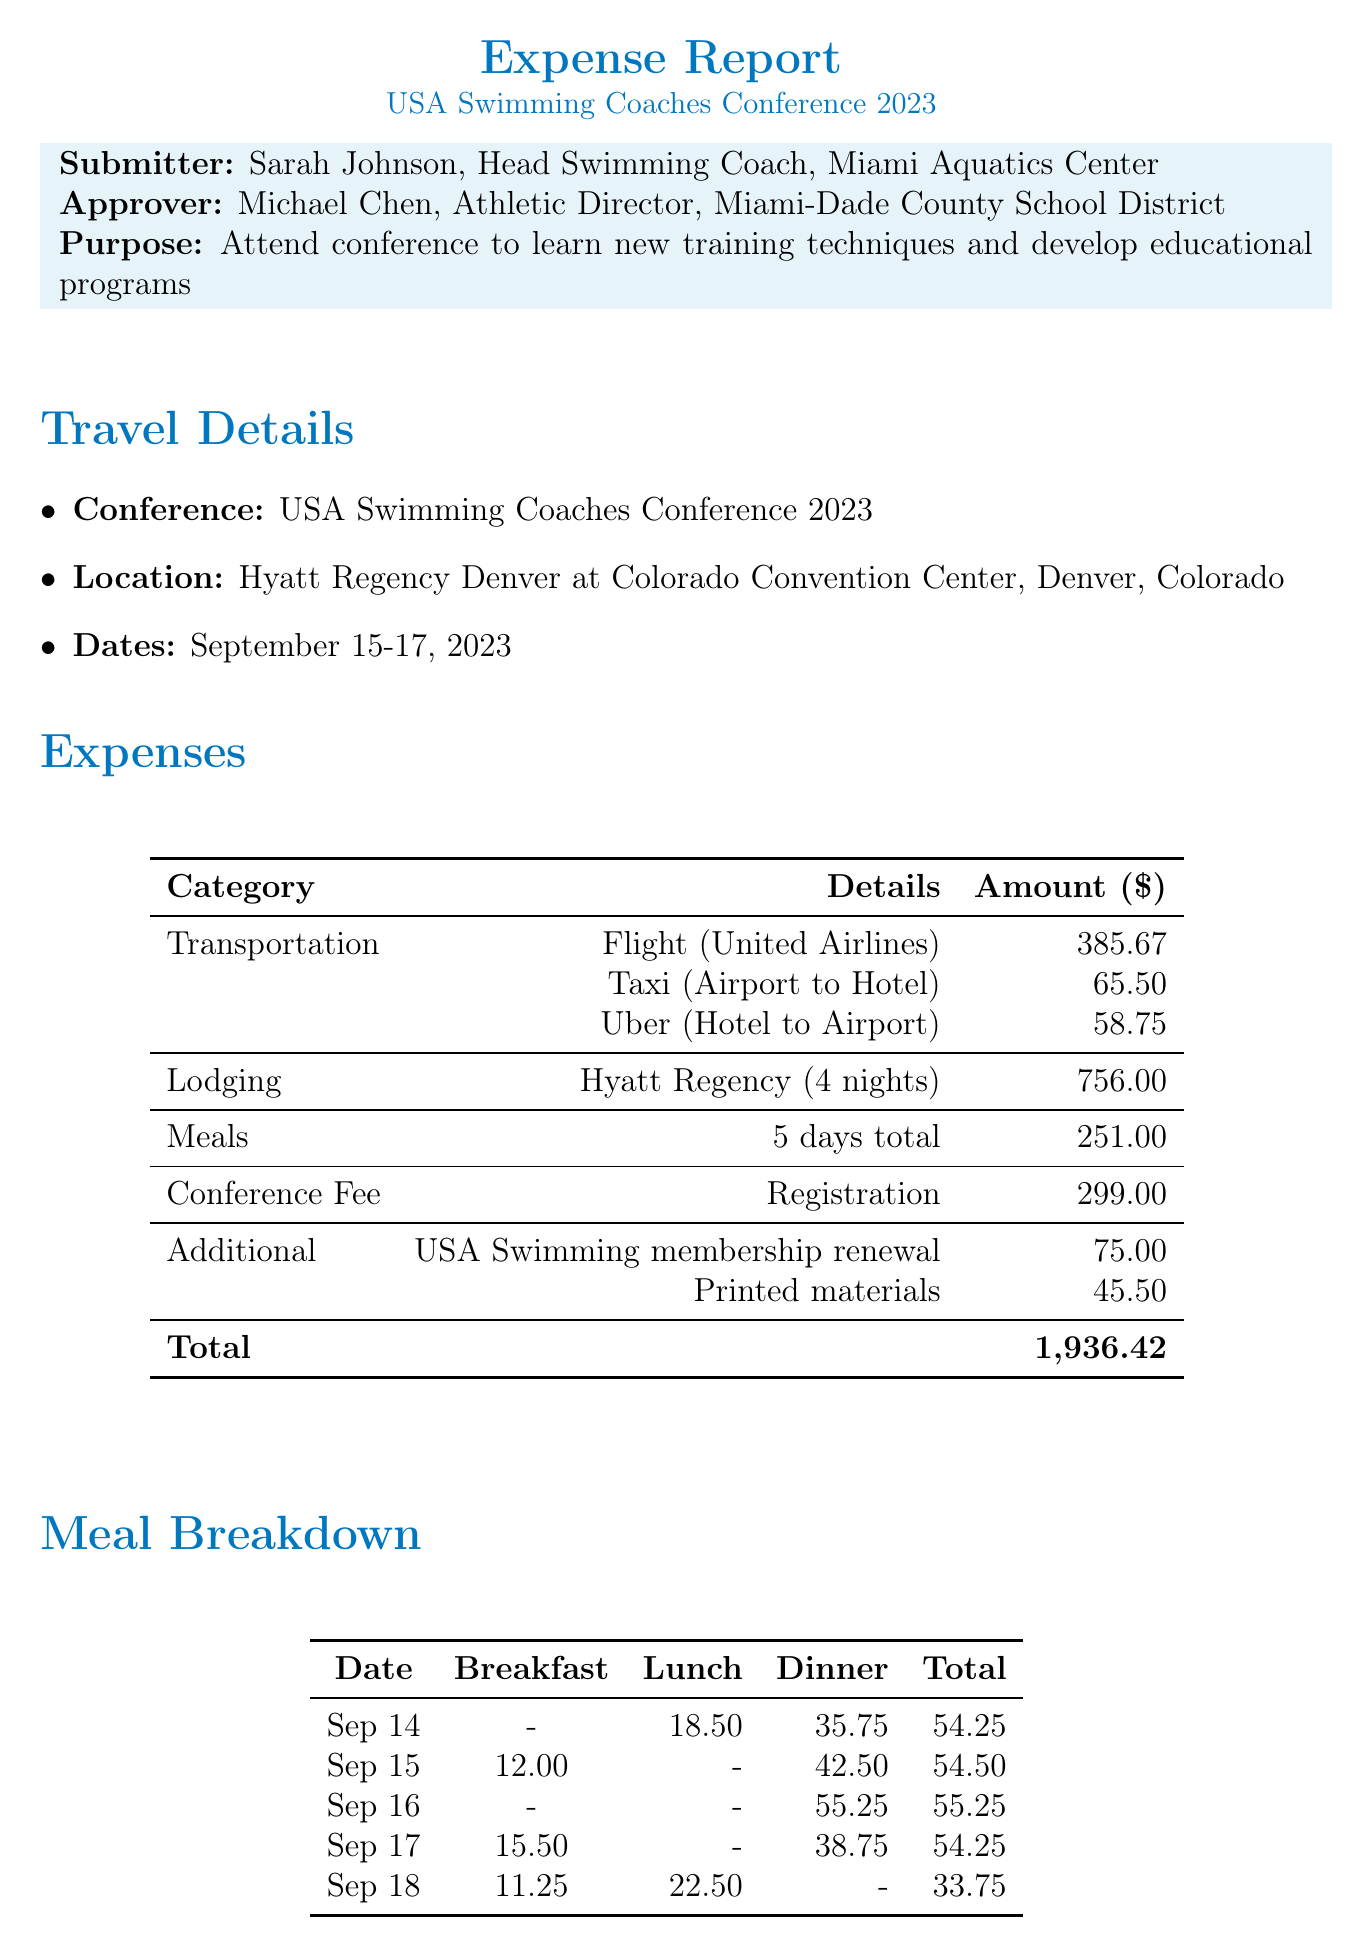What is the total cost of transportation? The total cost of transportation is the sum of flight, taxi, and Uber expenses, which is 385.67 + 65.50 + 58.75 = 509.92.
Answer: 509.92 What hotel was used for lodging? The document specifies the lodging hotel as Hyatt Regency Denver at Colorado Convention Center.
Answer: Hyatt Regency Denver at Colorado Convention Center What are the dates of the conference? The conference dates are explicitly mentioned in the document as September 15-17, 2023.
Answer: September 15-17, 2023 How much did the conference registration fee cost? The cost of the conference registration fee is listed in the additional expenses section as 299.00.
Answer: 299.00 How many nights did the lodging last? The document states that the lodging lasted for 4 nights.
Answer: 4 nights What is the total amount spent on meals? The total amount spent on meals is provided in the expenses summary as 251.00.
Answer: 251.00 Who is the expense submitter? The expense submitter is identified as Sarah Johnson, Head Swimming Coach at Miami Aquatics Center.
Answer: Sarah Johnson What type of transportation was used from the airport to the hotel? The document mentions that a taxi service was used for transportation from the airport to the hotel.
Answer: Taxi 